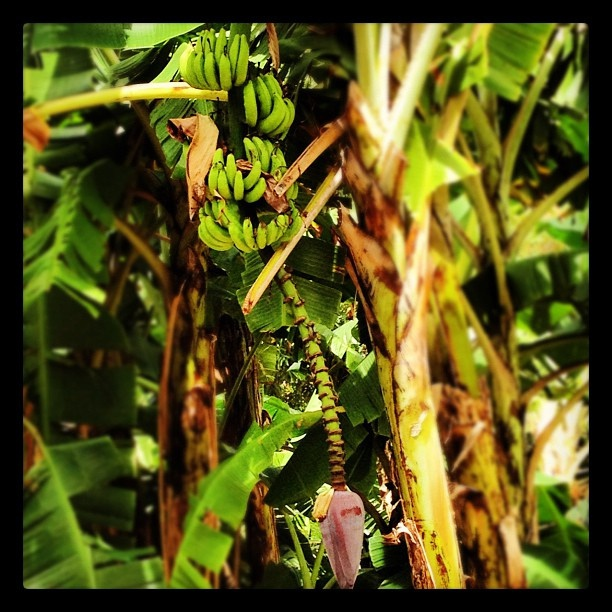Describe the objects in this image and their specific colors. I can see banana in black, olive, and khaki tones, banana in black, olive, khaki, and darkgreen tones, banana in black, olive, khaki, and yellow tones, banana in black, khaki, yellow, and olive tones, and banana in black, olive, and khaki tones in this image. 